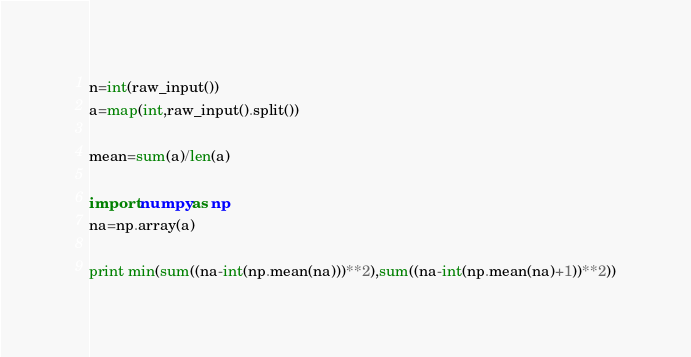<code> <loc_0><loc_0><loc_500><loc_500><_Python_>n=int(raw_input())
a=map(int,raw_input().split())

mean=sum(a)/len(a)

import numpy as np
na=np.array(a)

print min(sum((na-int(np.mean(na)))**2),sum((na-int(np.mean(na)+1))**2))</code> 